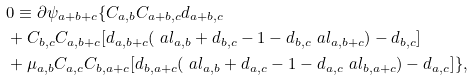<formula> <loc_0><loc_0><loc_500><loc_500>& 0 \equiv \partial \psi _ { a + b + c } \{ C _ { a , b } C _ { a + b , c } d _ { a + b , c } \\ & + C _ { b , c } C _ { a , b + c } [ d _ { a , b + c } ( \ a l _ { a , b } + d _ { b , c } - 1 - d _ { b , c } \ a l _ { a , b + c } ) - d _ { b , c } ] \\ & + \mu _ { a , b } C _ { a , c } C _ { b , a + c } [ d _ { b , a + c } ( \ a l _ { a , b } + d _ { a , c } - 1 - d _ { a , c } \ a l _ { b , a + c } ) - d _ { a , c } ] \} ,</formula> 